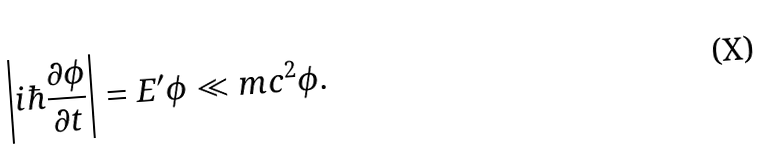Convert formula to latex. <formula><loc_0><loc_0><loc_500><loc_500>\left | i \hbar { \frac { \partial \phi } { \partial t } } \right | = E ^ { \prime } \phi \ll m c ^ { 2 } \phi .</formula> 